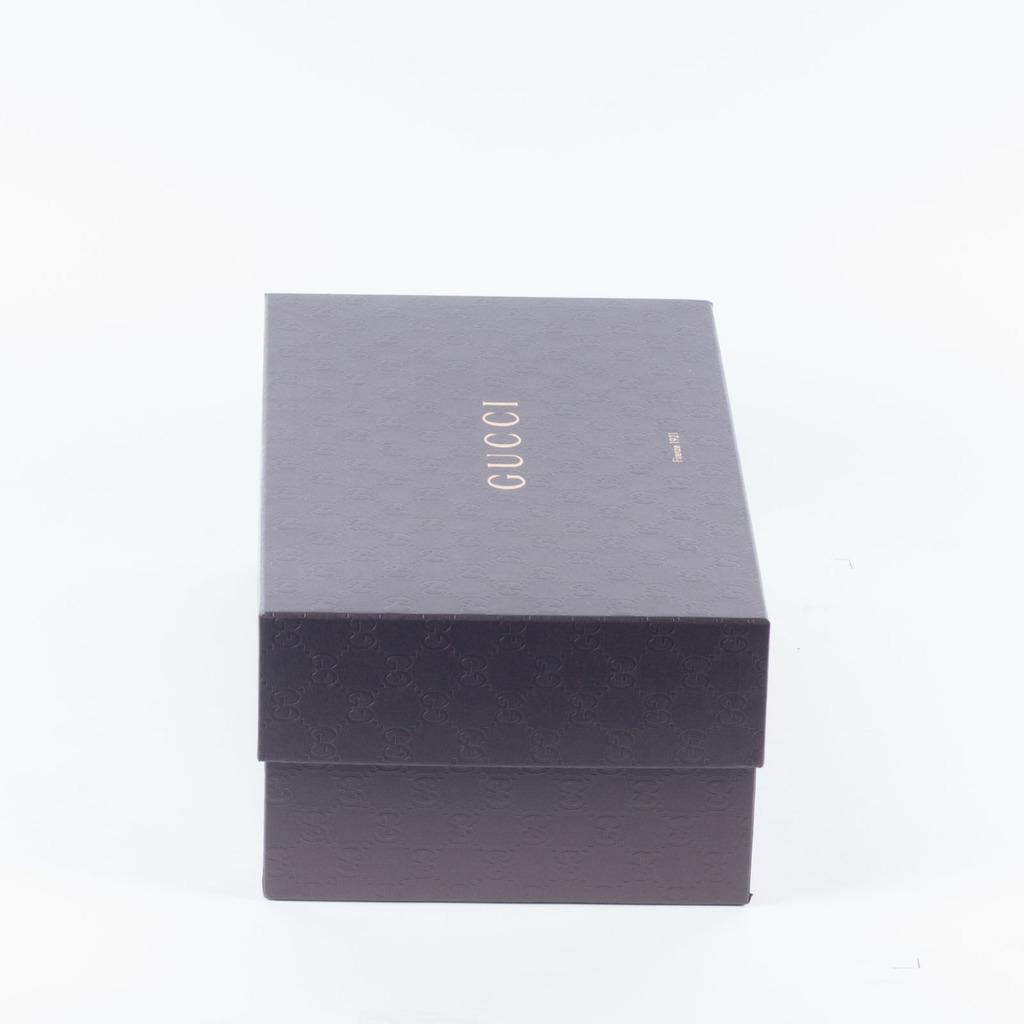<image>
Present a compact description of the photo's key features. A small Gucci box sits with the lid on. 